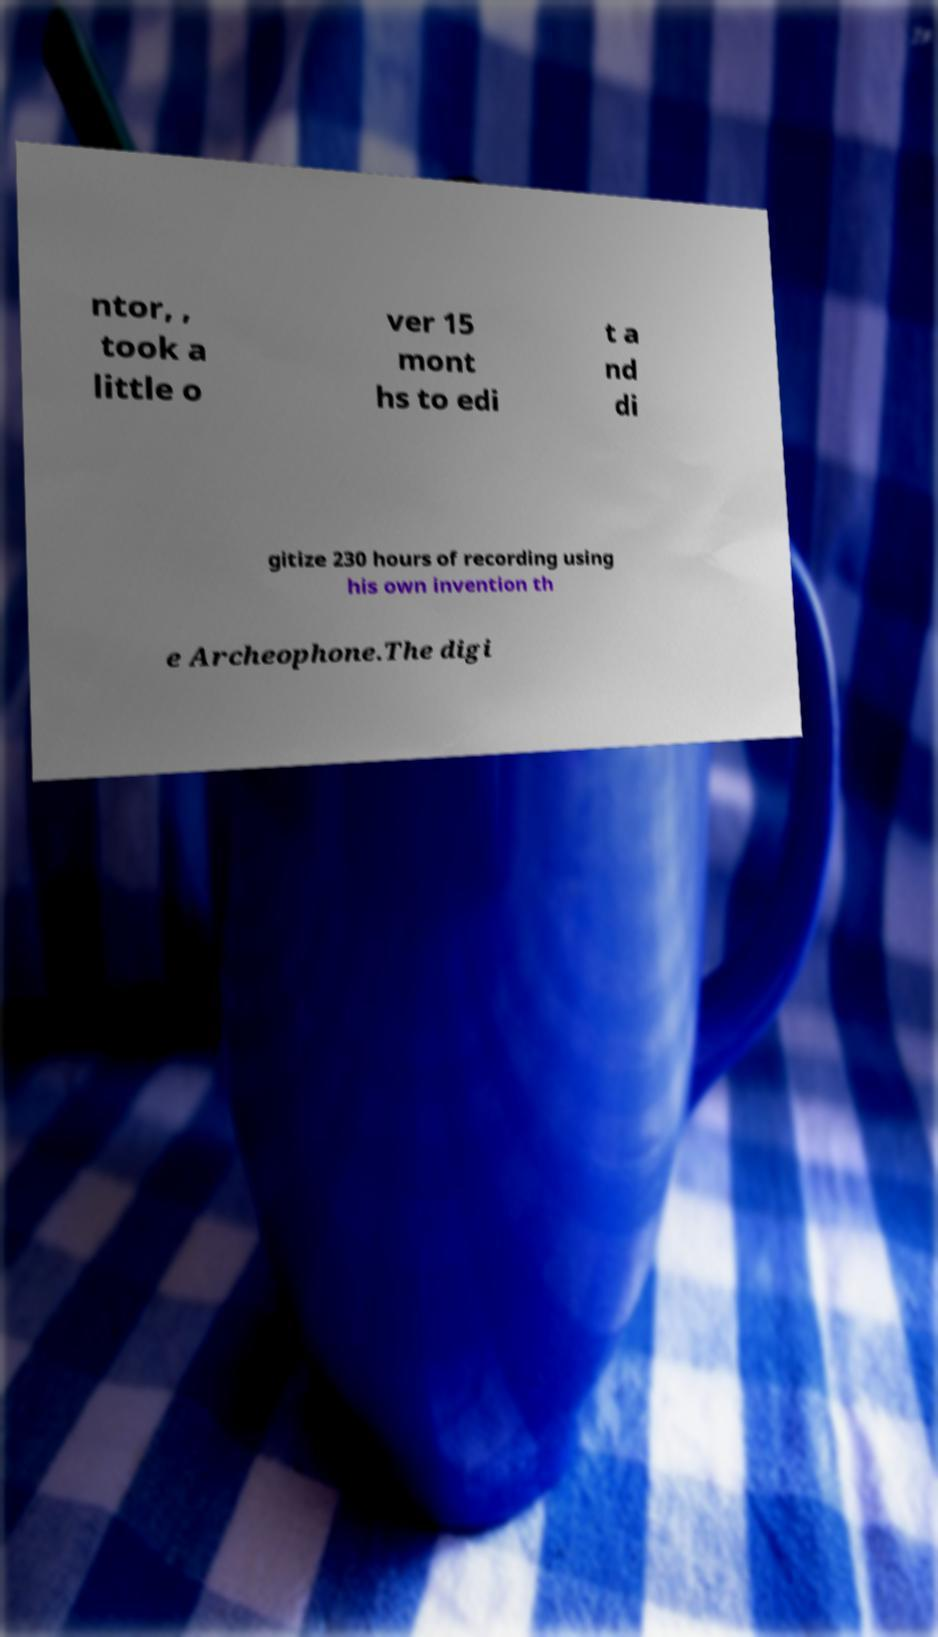Can you accurately transcribe the text from the provided image for me? ntor, , took a little o ver 15 mont hs to edi t a nd di gitize 230 hours of recording using his own invention th e Archeophone.The digi 